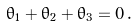Convert formula to latex. <formula><loc_0><loc_0><loc_500><loc_500>\theta _ { 1 } + \theta _ { 2 } + \theta _ { 3 } = 0 \, .</formula> 